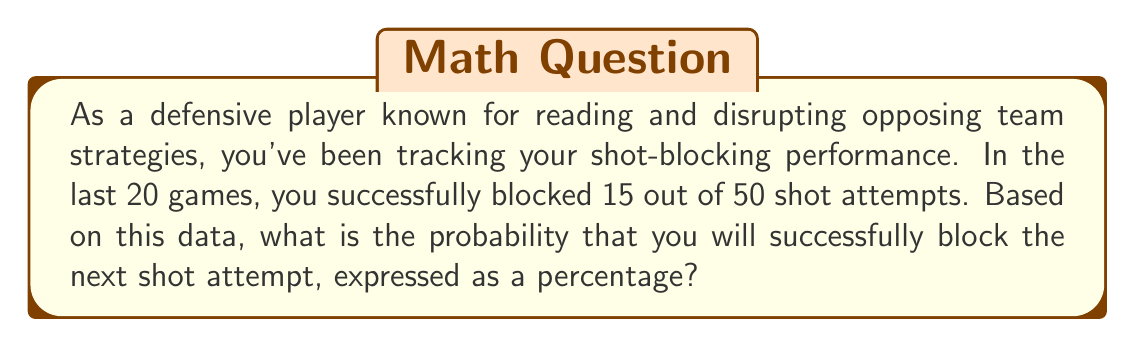Give your solution to this math problem. To solve this problem, we need to calculate the probability of a successful block based on past performance. Here's how we can approach it:

1. Identify the total number of shot attempts: 50
2. Identify the number of successful blocks: 15
3. Calculate the probability using the formula:

   $$P(\text{successful block}) = \frac{\text{number of successful blocks}}{\text{total number of shot attempts}}$$

4. Plug in the values:

   $$P(\text{successful block}) = \frac{15}{50}$$

5. Simplify the fraction:

   $$P(\text{successful block}) = \frac{3}{10} = 0.3$$

6. Convert to a percentage by multiplying by 100:

   $$0.3 \times 100 = 30\%$$

Therefore, based on your past performance, the probability of successfully blocking the next shot attempt is 30%.
Answer: 30% 